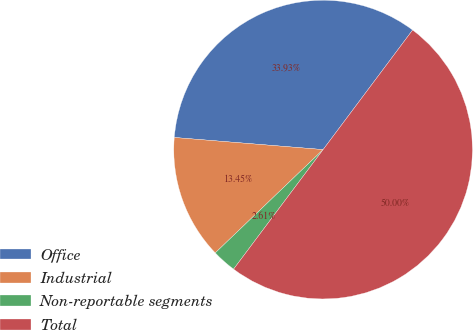Convert chart. <chart><loc_0><loc_0><loc_500><loc_500><pie_chart><fcel>Office<fcel>Industrial<fcel>Non-reportable segments<fcel>Total<nl><fcel>33.93%<fcel>13.45%<fcel>2.61%<fcel>50.0%<nl></chart> 